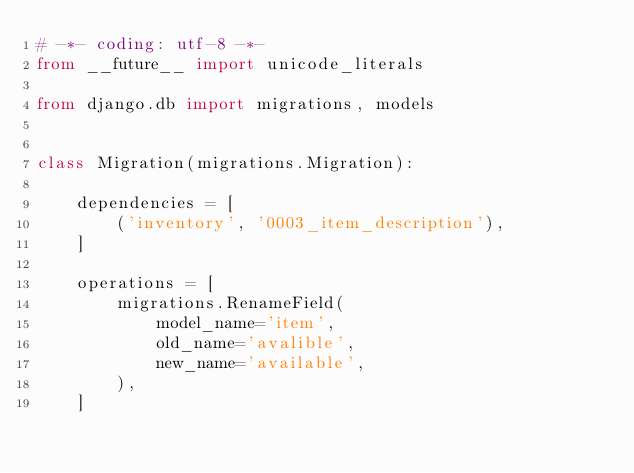<code> <loc_0><loc_0><loc_500><loc_500><_Python_># -*- coding: utf-8 -*-
from __future__ import unicode_literals

from django.db import migrations, models


class Migration(migrations.Migration):

    dependencies = [
        ('inventory', '0003_item_description'),
    ]

    operations = [
        migrations.RenameField(
            model_name='item',
            old_name='avalible',
            new_name='available',
        ),
    ]
</code> 